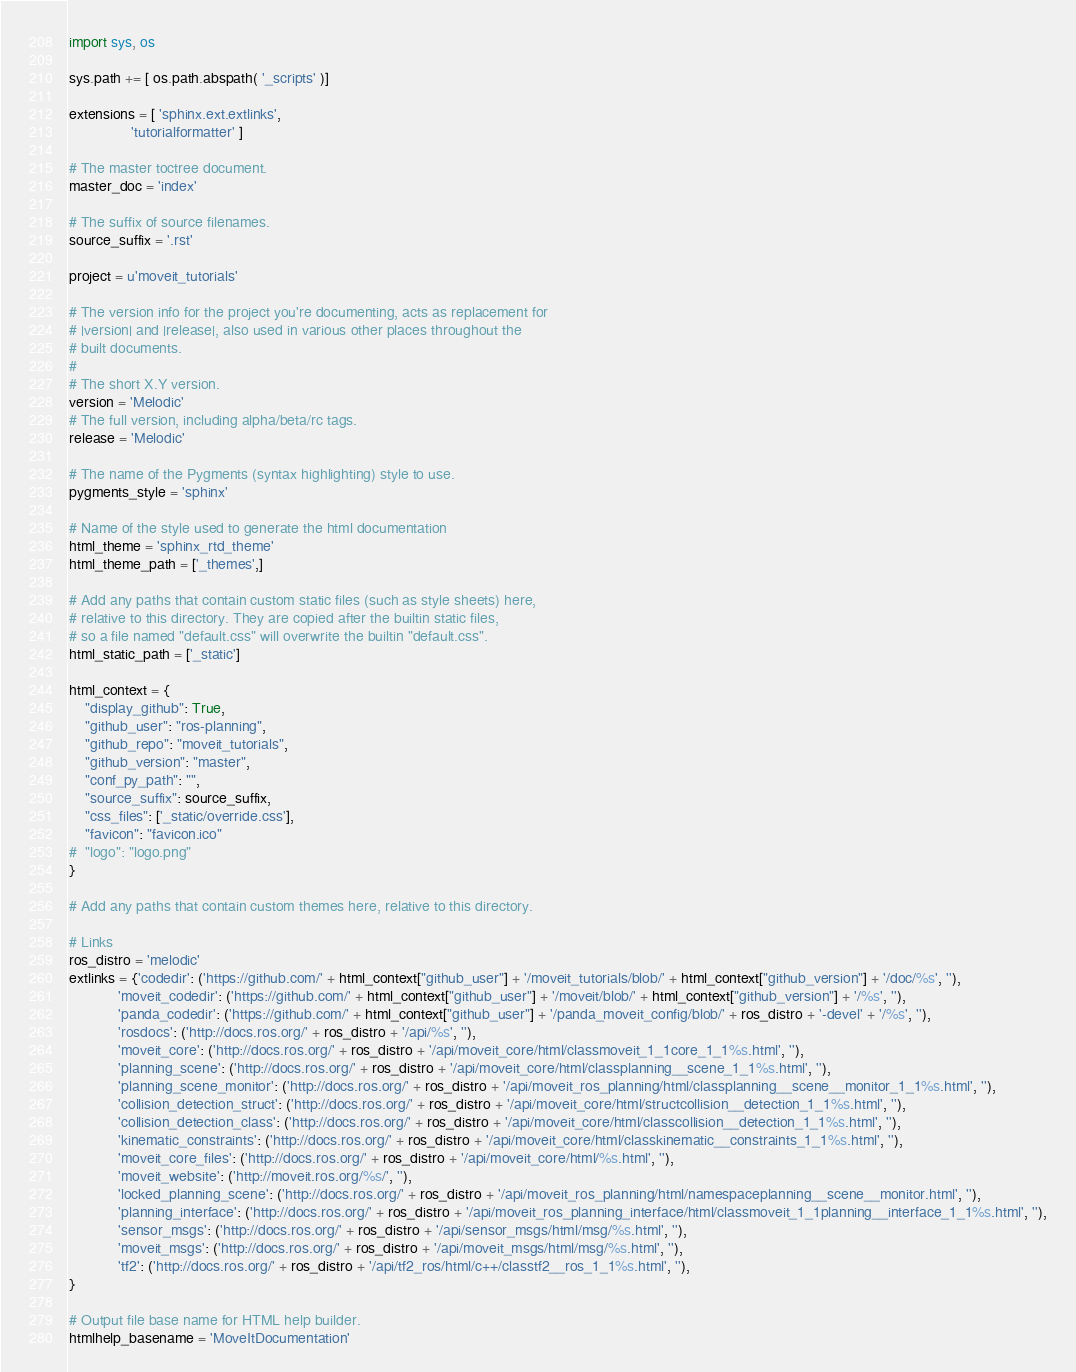Convert code to text. <code><loc_0><loc_0><loc_500><loc_500><_Python_>import sys, os

sys.path += [ os.path.abspath( '_scripts' )]

extensions = [ 'sphinx.ext.extlinks',
               'tutorialformatter' ]

# The master toctree document.
master_doc = 'index'

# The suffix of source filenames.
source_suffix = '.rst'

project = u'moveit_tutorials'

# The version info for the project you're documenting, acts as replacement for
# |version| and |release|, also used in various other places throughout the
# built documents.
#
# The short X.Y version.
version = 'Melodic'
# The full version, including alpha/beta/rc tags.
release = 'Melodic'

# The name of the Pygments (syntax highlighting) style to use.
pygments_style = 'sphinx'

# Name of the style used to generate the html documentation
html_theme = 'sphinx_rtd_theme'
html_theme_path = ['_themes',]

# Add any paths that contain custom static files (such as style sheets) here,
# relative to this directory. They are copied after the builtin static files,
# so a file named "default.css" will overwrite the builtin "default.css".
html_static_path = ['_static']

html_context = {
    "display_github": True,
    "github_user": "ros-planning",
    "github_repo": "moveit_tutorials",
    "github_version": "master",
    "conf_py_path": "",
    "source_suffix": source_suffix,
    "css_files": ['_static/override.css'],
    "favicon": "favicon.ico"
#  "logo": "logo.png"
}

# Add any paths that contain custom themes here, relative to this directory.

# Links
ros_distro = 'melodic'
extlinks = {'codedir': ('https://github.com/' + html_context["github_user"] + '/moveit_tutorials/blob/' + html_context["github_version"] + '/doc/%s', ''),
            'moveit_codedir': ('https://github.com/' + html_context["github_user"] + '/moveit/blob/' + html_context["github_version"] + '/%s', ''),
            'panda_codedir': ('https://github.com/' + html_context["github_user"] + '/panda_moveit_config/blob/' + ros_distro + '-devel' + '/%s', ''),
            'rosdocs': ('http://docs.ros.org/' + ros_distro + '/api/%s', ''),
            'moveit_core': ('http://docs.ros.org/' + ros_distro + '/api/moveit_core/html/classmoveit_1_1core_1_1%s.html', ''),
            'planning_scene': ('http://docs.ros.org/' + ros_distro + '/api/moveit_core/html/classplanning__scene_1_1%s.html', ''),
            'planning_scene_monitor': ('http://docs.ros.org/' + ros_distro + '/api/moveit_ros_planning/html/classplanning__scene__monitor_1_1%s.html', ''),
            'collision_detection_struct': ('http://docs.ros.org/' + ros_distro + '/api/moveit_core/html/structcollision__detection_1_1%s.html', ''),
            'collision_detection_class': ('http://docs.ros.org/' + ros_distro + '/api/moveit_core/html/classcollision__detection_1_1%s.html', ''),
            'kinematic_constraints': ('http://docs.ros.org/' + ros_distro + '/api/moveit_core/html/classkinematic__constraints_1_1%s.html', ''),
            'moveit_core_files': ('http://docs.ros.org/' + ros_distro + '/api/moveit_core/html/%s.html', ''),
            'moveit_website': ('http://moveit.ros.org/%s/', ''),
            'locked_planning_scene': ('http://docs.ros.org/' + ros_distro + '/api/moveit_ros_planning/html/namespaceplanning__scene__monitor.html', ''),
            'planning_interface': ('http://docs.ros.org/' + ros_distro + '/api/moveit_ros_planning_interface/html/classmoveit_1_1planning__interface_1_1%s.html', ''),
            'sensor_msgs': ('http://docs.ros.org/' + ros_distro + '/api/sensor_msgs/html/msg/%s.html', ''),
            'moveit_msgs': ('http://docs.ros.org/' + ros_distro + '/api/moveit_msgs/html/msg/%s.html', ''),
            'tf2': ('http://docs.ros.org/' + ros_distro + '/api/tf2_ros/html/c++/classtf2__ros_1_1%s.html', ''),
}

# Output file base name for HTML help builder.
htmlhelp_basename = 'MoveItDocumentation'
</code> 